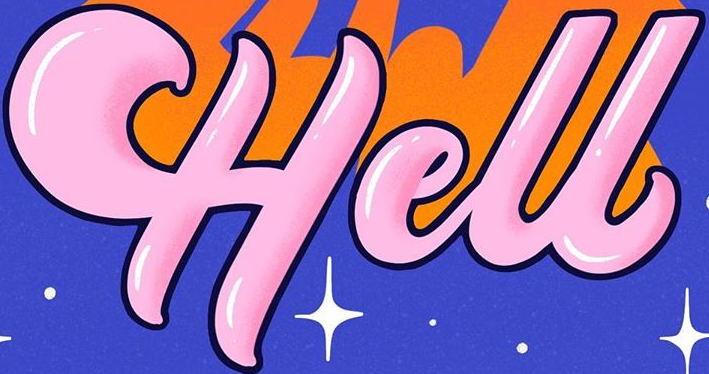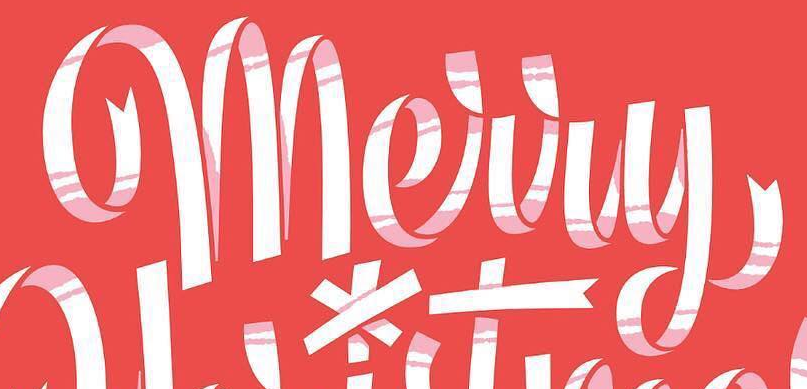What words are shown in these images in order, separated by a semicolon? Hell; Merry 